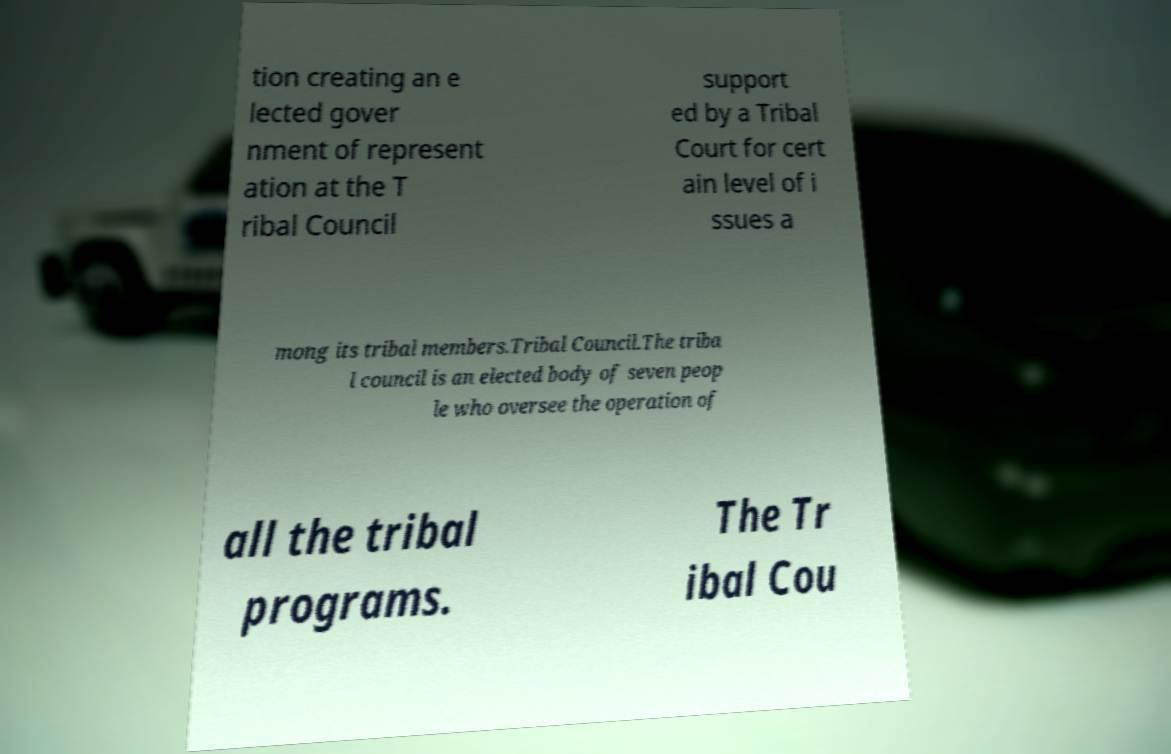Can you read and provide the text displayed in the image?This photo seems to have some interesting text. Can you extract and type it out for me? tion creating an e lected gover nment of represent ation at the T ribal Council support ed by a Tribal Court for cert ain level of i ssues a mong its tribal members.Tribal Council.The triba l council is an elected body of seven peop le who oversee the operation of all the tribal programs. The Tr ibal Cou 